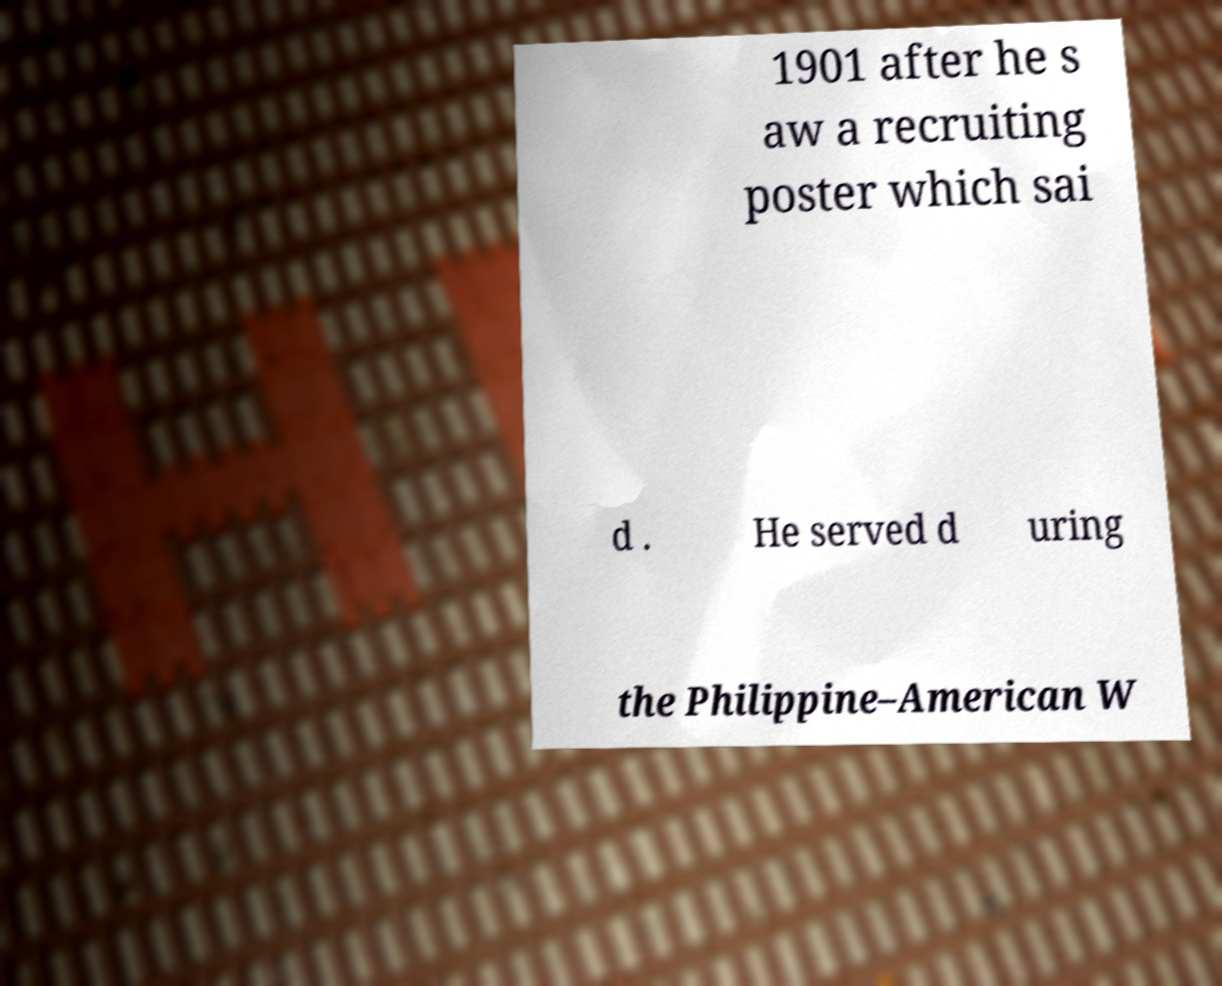Please identify and transcribe the text found in this image. 1901 after he s aw a recruiting poster which sai d . He served d uring the Philippine–American W 